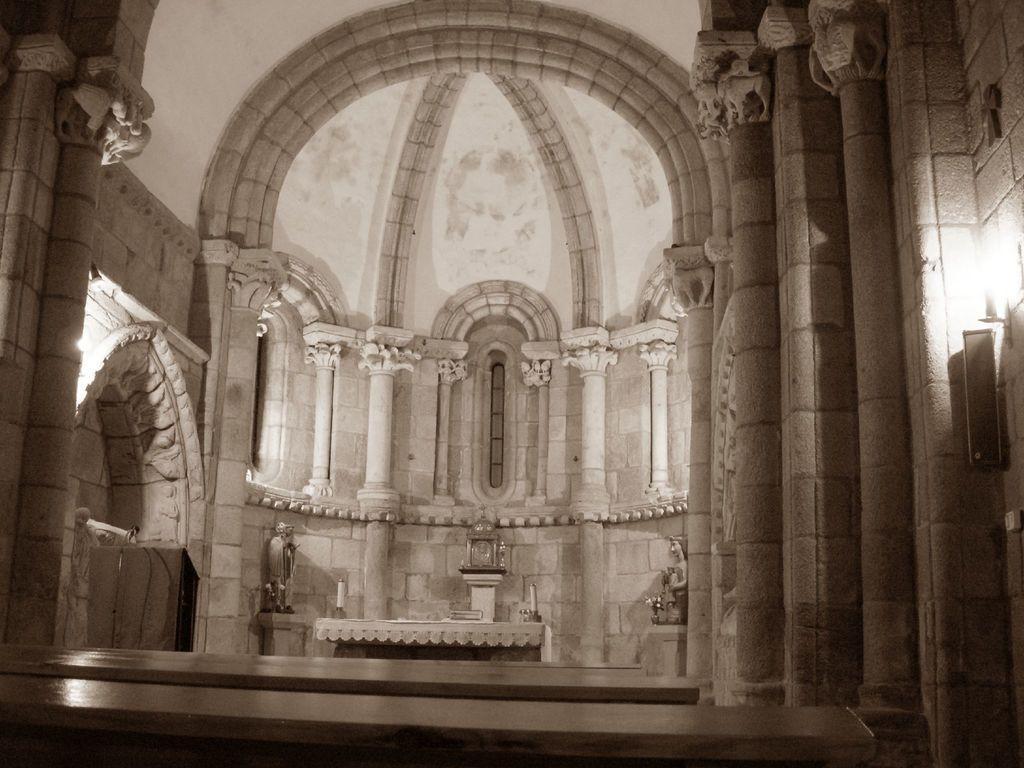How would you summarize this image in a sentence or two? In front of the image there are tables. In the background of the image there are some objects on the platforms. There is a table. On top of it there are some objects. There are carvings on the wall. There are lamps. On the right side of the image there is a speaker on the wall. 